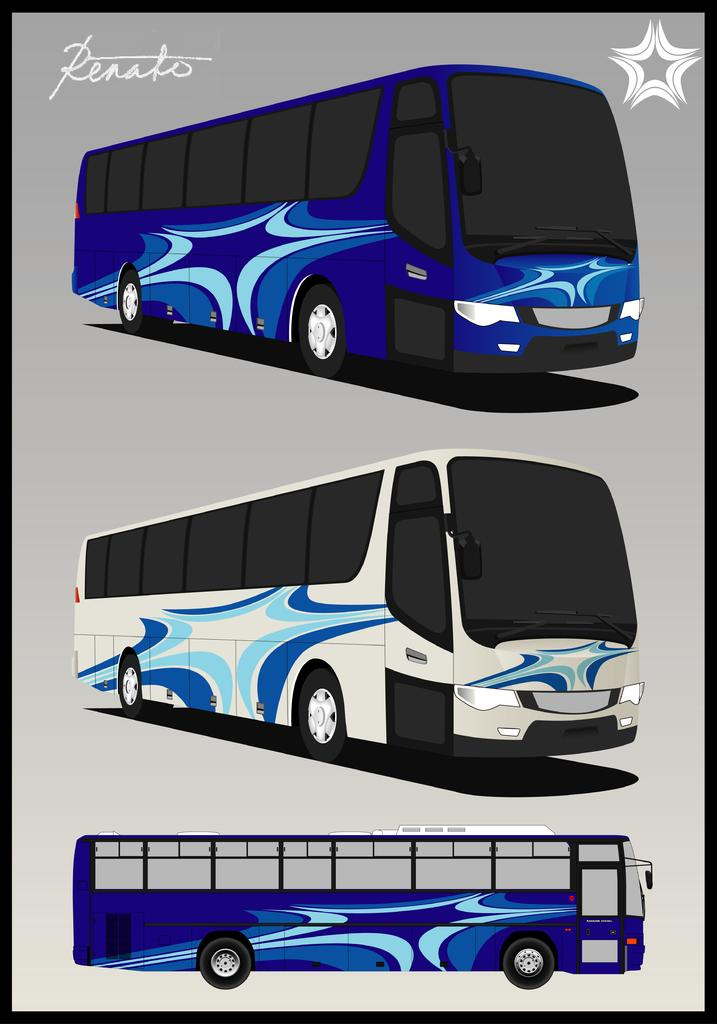How many people are depicted in the image? There are depictions of three persons in the image. What else can be found in the image besides the people? There is text in the image. What feature surrounds the content of the image? The image has borders. What type of riddle is being solved by the persons in the image? There is no riddle present in the image; it only depicts three persons and text. What flavor of eggnog is being consumed by the persons in the image? There is no eggnog present in the image; it only depicts three persons and text. 